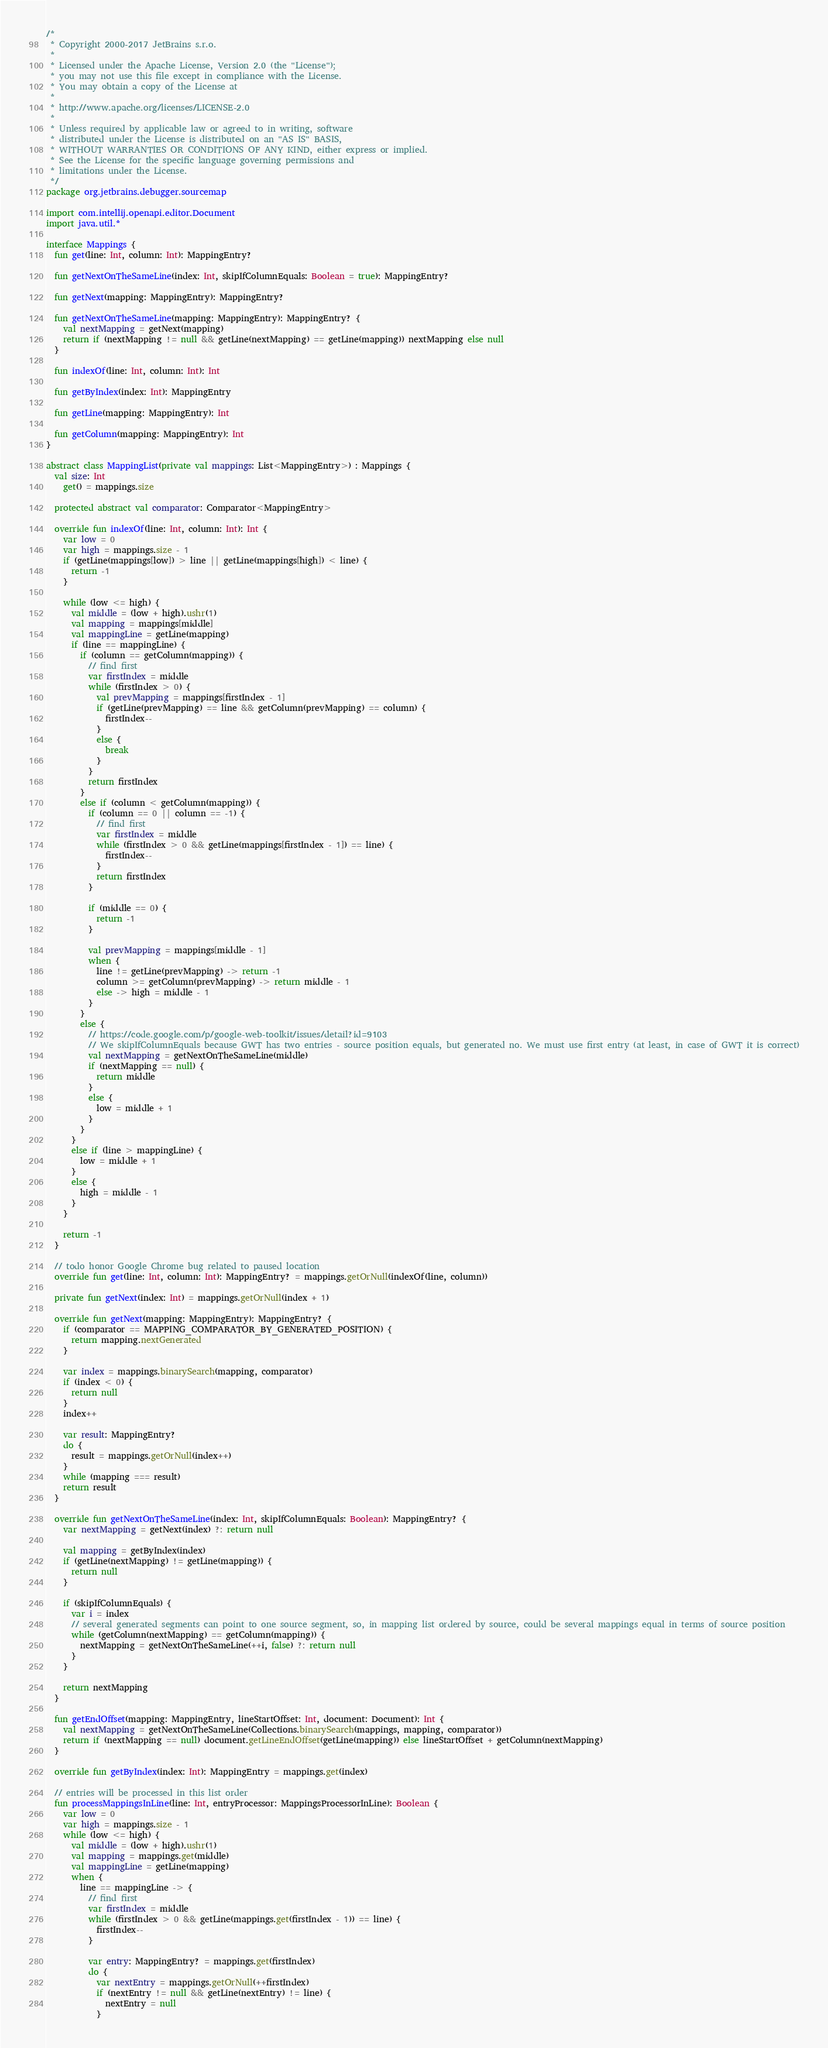Convert code to text. <code><loc_0><loc_0><loc_500><loc_500><_Kotlin_>/*
 * Copyright 2000-2017 JetBrains s.r.o.
 *
 * Licensed under the Apache License, Version 2.0 (the "License");
 * you may not use this file except in compliance with the License.
 * You may obtain a copy of the License at
 *
 * http://www.apache.org/licenses/LICENSE-2.0
 *
 * Unless required by applicable law or agreed to in writing, software
 * distributed under the License is distributed on an "AS IS" BASIS,
 * WITHOUT WARRANTIES OR CONDITIONS OF ANY KIND, either express or implied.
 * See the License for the specific language governing permissions and
 * limitations under the License.
 */
package org.jetbrains.debugger.sourcemap

import com.intellij.openapi.editor.Document
import java.util.*

interface Mappings {
  fun get(line: Int, column: Int): MappingEntry?

  fun getNextOnTheSameLine(index: Int, skipIfColumnEquals: Boolean = true): MappingEntry?

  fun getNext(mapping: MappingEntry): MappingEntry?

  fun getNextOnTheSameLine(mapping: MappingEntry): MappingEntry? {
    val nextMapping = getNext(mapping)
    return if (nextMapping != null && getLine(nextMapping) == getLine(mapping)) nextMapping else null
  }

  fun indexOf(line: Int, column: Int): Int

  fun getByIndex(index: Int): MappingEntry

  fun getLine(mapping: MappingEntry): Int

  fun getColumn(mapping: MappingEntry): Int
}

abstract class MappingList(private val mappings: List<MappingEntry>) : Mappings {
  val size: Int
    get() = mappings.size

  protected abstract val comparator: Comparator<MappingEntry>

  override fun indexOf(line: Int, column: Int): Int {
    var low = 0
    var high = mappings.size - 1
    if (getLine(mappings[low]) > line || getLine(mappings[high]) < line) {
      return -1
    }

    while (low <= high) {
      val middle = (low + high).ushr(1)
      val mapping = mappings[middle]
      val mappingLine = getLine(mapping)
      if (line == mappingLine) {
        if (column == getColumn(mapping)) {
          // find first
          var firstIndex = middle
          while (firstIndex > 0) {
            val prevMapping = mappings[firstIndex - 1]
            if (getLine(prevMapping) == line && getColumn(prevMapping) == column) {
              firstIndex--
            }
            else {
              break
            }
          }
          return firstIndex
        }
        else if (column < getColumn(mapping)) {
          if (column == 0 || column == -1) {
            // find first
            var firstIndex = middle
            while (firstIndex > 0 && getLine(mappings[firstIndex - 1]) == line) {
              firstIndex--
            }
            return firstIndex
          }

          if (middle == 0) {
            return -1
          }

          val prevMapping = mappings[middle - 1]
          when {
            line != getLine(prevMapping) -> return -1
            column >= getColumn(prevMapping) -> return middle - 1
            else -> high = middle - 1
          }
        }
        else {
          // https://code.google.com/p/google-web-toolkit/issues/detail?id=9103
          // We skipIfColumnEquals because GWT has two entries - source position equals, but generated no. We must use first entry (at least, in case of GWT it is correct)
          val nextMapping = getNextOnTheSameLine(middle)
          if (nextMapping == null) {
            return middle
          }
          else {
            low = middle + 1
          }
        }
      }
      else if (line > mappingLine) {
        low = middle + 1
      }
      else {
        high = middle - 1
      }
    }

    return -1
  }

  // todo honor Google Chrome bug related to paused location
  override fun get(line: Int, column: Int): MappingEntry? = mappings.getOrNull(indexOf(line, column))

  private fun getNext(index: Int) = mappings.getOrNull(index + 1)

  override fun getNext(mapping: MappingEntry): MappingEntry? {
    if (comparator == MAPPING_COMPARATOR_BY_GENERATED_POSITION) {
      return mapping.nextGenerated
    }

    var index = mappings.binarySearch(mapping, comparator)
    if (index < 0) {
      return null
    }
    index++

    var result: MappingEntry?
    do {
      result = mappings.getOrNull(index++)
    }
    while (mapping === result)
    return result
  }

  override fun getNextOnTheSameLine(index: Int, skipIfColumnEquals: Boolean): MappingEntry? {
    var nextMapping = getNext(index) ?: return null

    val mapping = getByIndex(index)
    if (getLine(nextMapping) != getLine(mapping)) {
      return null
    }

    if (skipIfColumnEquals) {
      var i = index
      // several generated segments can point to one source segment, so, in mapping list ordered by source, could be several mappings equal in terms of source position
      while (getColumn(nextMapping) == getColumn(mapping)) {
        nextMapping = getNextOnTheSameLine(++i, false) ?: return null
      }
    }

    return nextMapping
  }

  fun getEndOffset(mapping: MappingEntry, lineStartOffset: Int, document: Document): Int {
    val nextMapping = getNextOnTheSameLine(Collections.binarySearch(mappings, mapping, comparator))
    return if (nextMapping == null) document.getLineEndOffset(getLine(mapping)) else lineStartOffset + getColumn(nextMapping)
  }

  override fun getByIndex(index: Int): MappingEntry = mappings.get(index)

  // entries will be processed in this list order
  fun processMappingsInLine(line: Int, entryProcessor: MappingsProcessorInLine): Boolean {
    var low = 0
    var high = mappings.size - 1
    while (low <= high) {
      val middle = (low + high).ushr(1)
      val mapping = mappings.get(middle)
      val mappingLine = getLine(mapping)
      when {
        line == mappingLine -> {
          // find first
          var firstIndex = middle
          while (firstIndex > 0 && getLine(mappings.get(firstIndex - 1)) == line) {
            firstIndex--
          }

          var entry: MappingEntry? = mappings.get(firstIndex)
          do {
            var nextEntry = mappings.getOrNull(++firstIndex)
            if (nextEntry != null && getLine(nextEntry) != line) {
              nextEntry = null
            }
</code> 